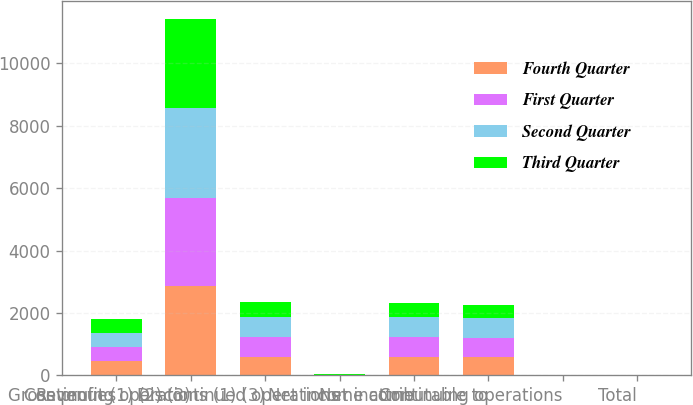Convert chart. <chart><loc_0><loc_0><loc_500><loc_500><stacked_bar_chart><ecel><fcel>Revenues<fcel>Gross profit (1) (2) (3)<fcel>Continuing operations (1) (3)<fcel>Discontinued operations<fcel>Net income<fcel>Net income attributable to<fcel>Continuing operations<fcel>Total<nl><fcel>Fourth Quarter<fcel>454.5<fcel>2848<fcel>599<fcel>10<fcel>589<fcel>576<fcel>2.5<fcel>2.45<nl><fcel>First Quarter<fcel>454.5<fcel>2844<fcel>636<fcel>6<fcel>630<fcel>617<fcel>2.65<fcel>2.63<nl><fcel>Second Quarter<fcel>454.5<fcel>2872<fcel>642<fcel>5<fcel>647<fcel>634<fcel>2.71<fcel>2.73<nl><fcel>Third Quarter<fcel>454.5<fcel>2852<fcel>465<fcel>21<fcel>444<fcel>431<fcel>1.97<fcel>1.88<nl></chart> 